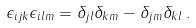<formula> <loc_0><loc_0><loc_500><loc_500>\epsilon _ { i j k } \epsilon _ { i l m } = \delta _ { j l } \delta _ { k m } - \delta _ { j m } \delta _ { k l } \, .</formula> 